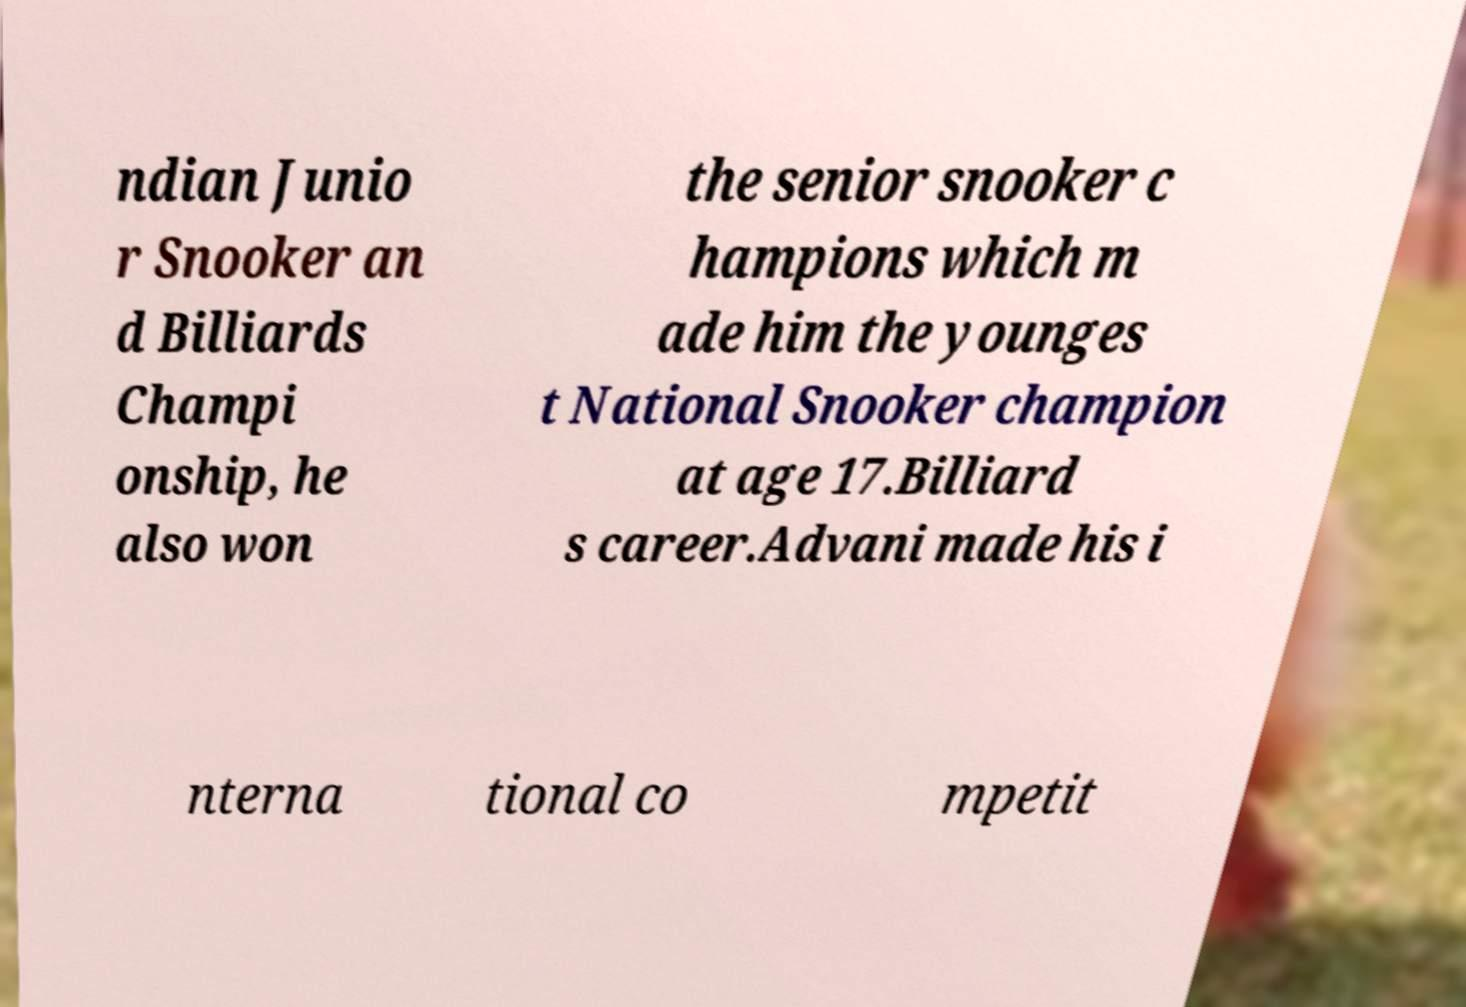I need the written content from this picture converted into text. Can you do that? ndian Junio r Snooker an d Billiards Champi onship, he also won the senior snooker c hampions which m ade him the younges t National Snooker champion at age 17.Billiard s career.Advani made his i nterna tional co mpetit 